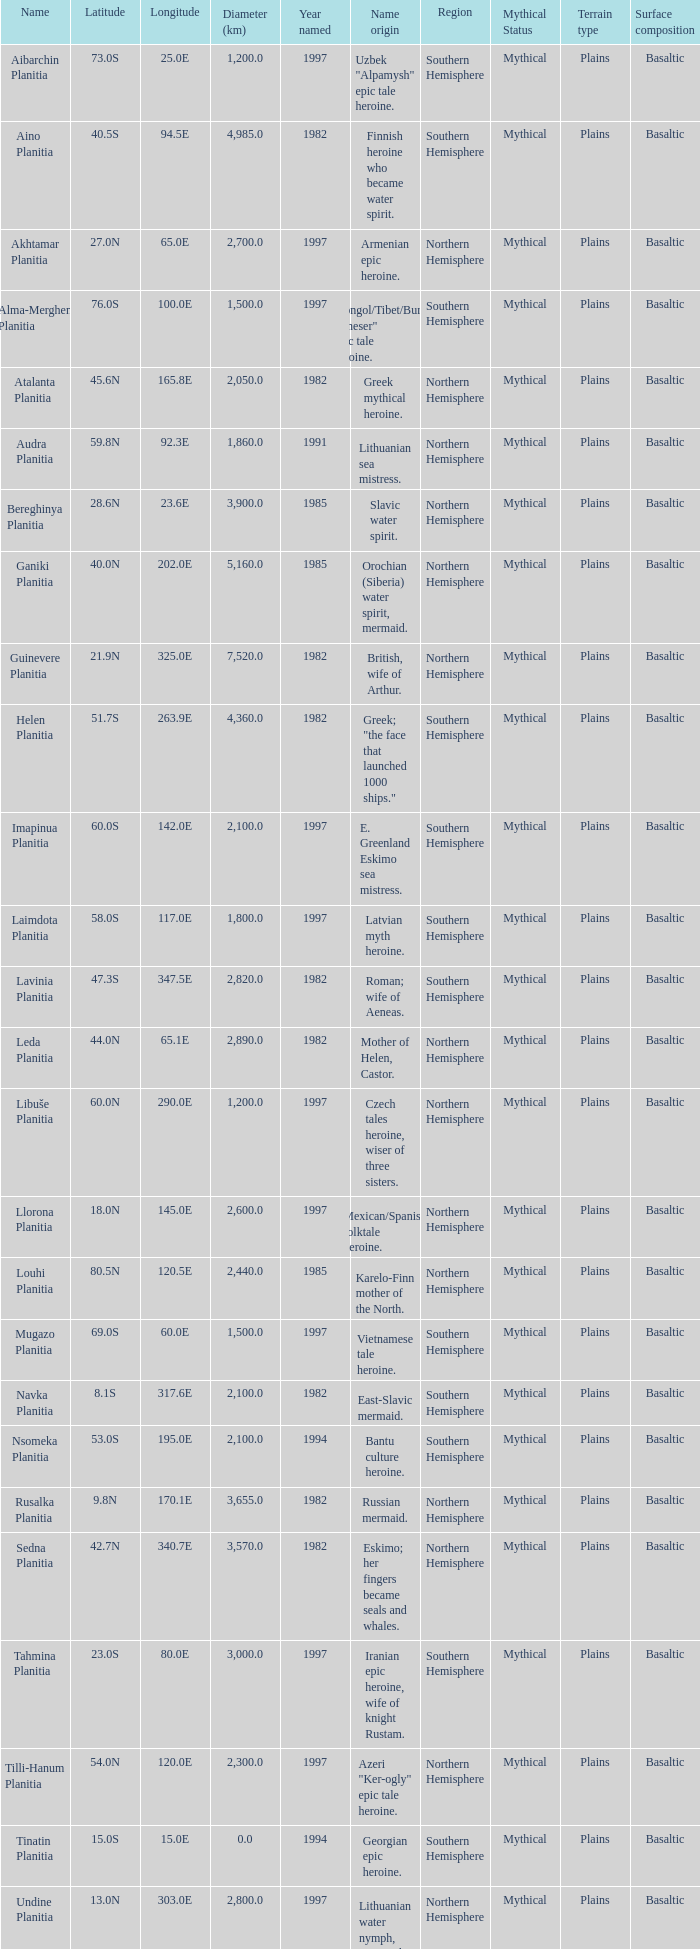What is the diameter (km) of the feature of latitude 23.0s 3000.0. 